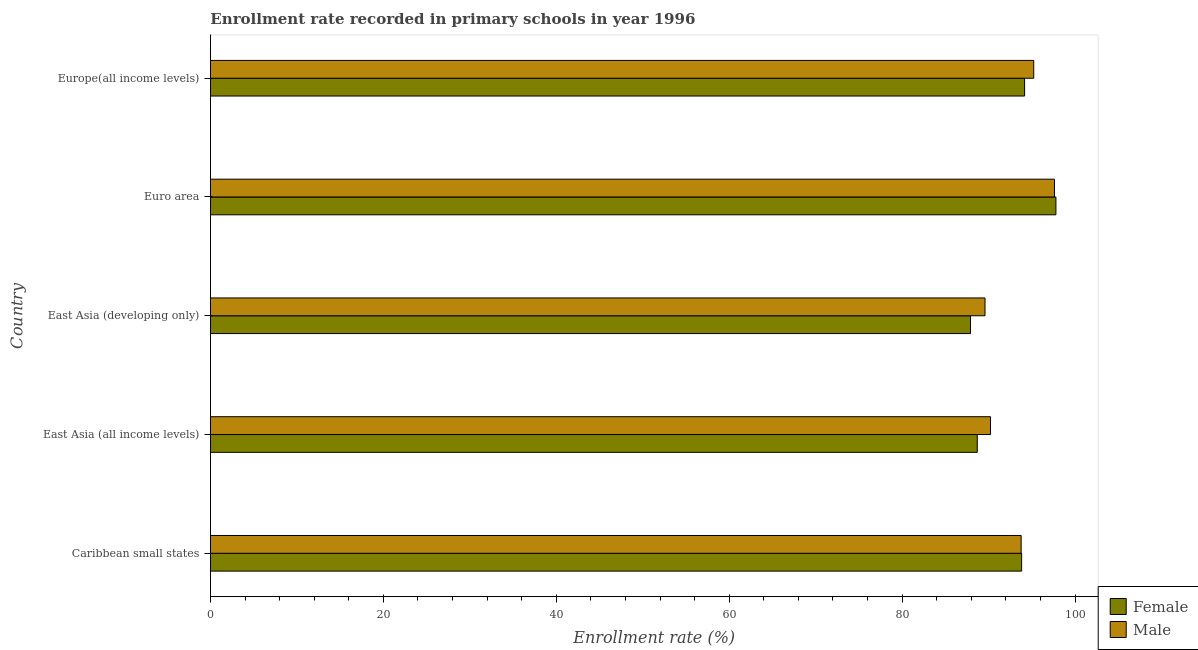How many groups of bars are there?
Ensure brevity in your answer.  5. Are the number of bars per tick equal to the number of legend labels?
Your answer should be compact. Yes. How many bars are there on the 4th tick from the top?
Provide a short and direct response. 2. What is the label of the 4th group of bars from the top?
Your answer should be compact. East Asia (all income levels). In how many cases, is the number of bars for a given country not equal to the number of legend labels?
Provide a short and direct response. 0. What is the enrollment rate of female students in East Asia (all income levels)?
Give a very brief answer. 88.69. Across all countries, what is the maximum enrollment rate of female students?
Ensure brevity in your answer.  97.79. Across all countries, what is the minimum enrollment rate of female students?
Your answer should be compact. 87.91. In which country was the enrollment rate of male students maximum?
Your response must be concise. Euro area. In which country was the enrollment rate of female students minimum?
Offer a very short reply. East Asia (developing only). What is the total enrollment rate of female students in the graph?
Your answer should be very brief. 462.38. What is the difference between the enrollment rate of male students in East Asia (all income levels) and that in Euro area?
Provide a succinct answer. -7.4. What is the difference between the enrollment rate of female students in Europe(all income levels) and the enrollment rate of male students in East Asia (all income levels)?
Offer a very short reply. 3.94. What is the average enrollment rate of female students per country?
Your answer should be very brief. 92.48. What is the difference between the enrollment rate of female students and enrollment rate of male students in Euro area?
Offer a terse response. 0.17. In how many countries, is the enrollment rate of female students greater than 80 %?
Keep it short and to the point. 5. What is the ratio of the enrollment rate of male students in East Asia (developing only) to that in Europe(all income levels)?
Your answer should be compact. 0.94. Is the difference between the enrollment rate of male students in Euro area and Europe(all income levels) greater than the difference between the enrollment rate of female students in Euro area and Europe(all income levels)?
Provide a short and direct response. No. What is the difference between the highest and the second highest enrollment rate of female students?
Offer a very short reply. 3.62. What is the difference between the highest and the lowest enrollment rate of female students?
Your answer should be compact. 9.88. Is the sum of the enrollment rate of male students in Caribbean small states and Europe(all income levels) greater than the maximum enrollment rate of female students across all countries?
Your answer should be very brief. Yes. What does the 1st bar from the top in Europe(all income levels) represents?
Provide a short and direct response. Male. How many bars are there?
Your answer should be very brief. 10. How many legend labels are there?
Make the answer very short. 2. What is the title of the graph?
Your answer should be compact. Enrollment rate recorded in primary schools in year 1996. Does "IMF concessional" appear as one of the legend labels in the graph?
Give a very brief answer. No. What is the label or title of the X-axis?
Your response must be concise. Enrollment rate (%). What is the label or title of the Y-axis?
Your answer should be compact. Country. What is the Enrollment rate (%) in Female in Caribbean small states?
Provide a succinct answer. 93.82. What is the Enrollment rate (%) in Male in Caribbean small states?
Keep it short and to the point. 93.77. What is the Enrollment rate (%) in Female in East Asia (all income levels)?
Provide a short and direct response. 88.69. What is the Enrollment rate (%) of Male in East Asia (all income levels)?
Your response must be concise. 90.22. What is the Enrollment rate (%) in Female in East Asia (developing only)?
Provide a succinct answer. 87.91. What is the Enrollment rate (%) in Male in East Asia (developing only)?
Provide a short and direct response. 89.59. What is the Enrollment rate (%) of Female in Euro area?
Your answer should be very brief. 97.79. What is the Enrollment rate (%) in Male in Euro area?
Give a very brief answer. 97.62. What is the Enrollment rate (%) in Female in Europe(all income levels)?
Your answer should be very brief. 94.16. What is the Enrollment rate (%) of Male in Europe(all income levels)?
Give a very brief answer. 95.22. Across all countries, what is the maximum Enrollment rate (%) of Female?
Provide a succinct answer. 97.79. Across all countries, what is the maximum Enrollment rate (%) of Male?
Offer a very short reply. 97.62. Across all countries, what is the minimum Enrollment rate (%) in Female?
Offer a very short reply. 87.91. Across all countries, what is the minimum Enrollment rate (%) of Male?
Your answer should be compact. 89.59. What is the total Enrollment rate (%) of Female in the graph?
Keep it short and to the point. 462.38. What is the total Enrollment rate (%) of Male in the graph?
Provide a succinct answer. 466.42. What is the difference between the Enrollment rate (%) in Female in Caribbean small states and that in East Asia (all income levels)?
Keep it short and to the point. 5.13. What is the difference between the Enrollment rate (%) of Male in Caribbean small states and that in East Asia (all income levels)?
Offer a very short reply. 3.54. What is the difference between the Enrollment rate (%) in Female in Caribbean small states and that in East Asia (developing only)?
Your answer should be compact. 5.91. What is the difference between the Enrollment rate (%) of Male in Caribbean small states and that in East Asia (developing only)?
Your answer should be very brief. 4.18. What is the difference between the Enrollment rate (%) of Female in Caribbean small states and that in Euro area?
Offer a very short reply. -3.97. What is the difference between the Enrollment rate (%) in Male in Caribbean small states and that in Euro area?
Ensure brevity in your answer.  -3.86. What is the difference between the Enrollment rate (%) of Female in Caribbean small states and that in Europe(all income levels)?
Your response must be concise. -0.34. What is the difference between the Enrollment rate (%) in Male in Caribbean small states and that in Europe(all income levels)?
Offer a terse response. -1.46. What is the difference between the Enrollment rate (%) of Female in East Asia (all income levels) and that in East Asia (developing only)?
Keep it short and to the point. 0.78. What is the difference between the Enrollment rate (%) of Male in East Asia (all income levels) and that in East Asia (developing only)?
Offer a terse response. 0.64. What is the difference between the Enrollment rate (%) of Female in East Asia (all income levels) and that in Euro area?
Your answer should be compact. -9.1. What is the difference between the Enrollment rate (%) in Male in East Asia (all income levels) and that in Euro area?
Provide a short and direct response. -7.4. What is the difference between the Enrollment rate (%) of Female in East Asia (all income levels) and that in Europe(all income levels)?
Ensure brevity in your answer.  -5.47. What is the difference between the Enrollment rate (%) in Male in East Asia (all income levels) and that in Europe(all income levels)?
Your response must be concise. -5. What is the difference between the Enrollment rate (%) of Female in East Asia (developing only) and that in Euro area?
Make the answer very short. -9.88. What is the difference between the Enrollment rate (%) in Male in East Asia (developing only) and that in Euro area?
Provide a succinct answer. -8.04. What is the difference between the Enrollment rate (%) of Female in East Asia (developing only) and that in Europe(all income levels)?
Give a very brief answer. -6.26. What is the difference between the Enrollment rate (%) in Male in East Asia (developing only) and that in Europe(all income levels)?
Make the answer very short. -5.64. What is the difference between the Enrollment rate (%) in Female in Euro area and that in Europe(all income levels)?
Offer a terse response. 3.62. What is the difference between the Enrollment rate (%) in Male in Euro area and that in Europe(all income levels)?
Keep it short and to the point. 2.4. What is the difference between the Enrollment rate (%) of Female in Caribbean small states and the Enrollment rate (%) of Male in East Asia (all income levels)?
Offer a very short reply. 3.6. What is the difference between the Enrollment rate (%) of Female in Caribbean small states and the Enrollment rate (%) of Male in East Asia (developing only)?
Keep it short and to the point. 4.24. What is the difference between the Enrollment rate (%) of Female in Caribbean small states and the Enrollment rate (%) of Male in Euro area?
Your response must be concise. -3.8. What is the difference between the Enrollment rate (%) of Female in Caribbean small states and the Enrollment rate (%) of Male in Europe(all income levels)?
Offer a terse response. -1.4. What is the difference between the Enrollment rate (%) of Female in East Asia (all income levels) and the Enrollment rate (%) of Male in East Asia (developing only)?
Your answer should be very brief. -0.9. What is the difference between the Enrollment rate (%) of Female in East Asia (all income levels) and the Enrollment rate (%) of Male in Euro area?
Your response must be concise. -8.93. What is the difference between the Enrollment rate (%) of Female in East Asia (all income levels) and the Enrollment rate (%) of Male in Europe(all income levels)?
Provide a short and direct response. -6.53. What is the difference between the Enrollment rate (%) of Female in East Asia (developing only) and the Enrollment rate (%) of Male in Euro area?
Your answer should be very brief. -9.71. What is the difference between the Enrollment rate (%) in Female in East Asia (developing only) and the Enrollment rate (%) in Male in Europe(all income levels)?
Your answer should be very brief. -7.31. What is the difference between the Enrollment rate (%) of Female in Euro area and the Enrollment rate (%) of Male in Europe(all income levels)?
Provide a short and direct response. 2.57. What is the average Enrollment rate (%) in Female per country?
Make the answer very short. 92.48. What is the average Enrollment rate (%) of Male per country?
Provide a succinct answer. 93.28. What is the difference between the Enrollment rate (%) of Female and Enrollment rate (%) of Male in Caribbean small states?
Provide a short and direct response. 0.06. What is the difference between the Enrollment rate (%) in Female and Enrollment rate (%) in Male in East Asia (all income levels)?
Your answer should be very brief. -1.53. What is the difference between the Enrollment rate (%) in Female and Enrollment rate (%) in Male in East Asia (developing only)?
Offer a terse response. -1.68. What is the difference between the Enrollment rate (%) in Female and Enrollment rate (%) in Male in Euro area?
Provide a succinct answer. 0.17. What is the difference between the Enrollment rate (%) of Female and Enrollment rate (%) of Male in Europe(all income levels)?
Provide a succinct answer. -1.06. What is the ratio of the Enrollment rate (%) of Female in Caribbean small states to that in East Asia (all income levels)?
Keep it short and to the point. 1.06. What is the ratio of the Enrollment rate (%) of Male in Caribbean small states to that in East Asia (all income levels)?
Your response must be concise. 1.04. What is the ratio of the Enrollment rate (%) in Female in Caribbean small states to that in East Asia (developing only)?
Give a very brief answer. 1.07. What is the ratio of the Enrollment rate (%) in Male in Caribbean small states to that in East Asia (developing only)?
Your answer should be very brief. 1.05. What is the ratio of the Enrollment rate (%) of Female in Caribbean small states to that in Euro area?
Give a very brief answer. 0.96. What is the ratio of the Enrollment rate (%) in Male in Caribbean small states to that in Euro area?
Your answer should be very brief. 0.96. What is the ratio of the Enrollment rate (%) of Female in Caribbean small states to that in Europe(all income levels)?
Your answer should be compact. 1. What is the ratio of the Enrollment rate (%) of Male in Caribbean small states to that in Europe(all income levels)?
Offer a very short reply. 0.98. What is the ratio of the Enrollment rate (%) in Female in East Asia (all income levels) to that in East Asia (developing only)?
Ensure brevity in your answer.  1.01. What is the ratio of the Enrollment rate (%) of Male in East Asia (all income levels) to that in East Asia (developing only)?
Provide a short and direct response. 1.01. What is the ratio of the Enrollment rate (%) in Female in East Asia (all income levels) to that in Euro area?
Provide a succinct answer. 0.91. What is the ratio of the Enrollment rate (%) in Male in East Asia (all income levels) to that in Euro area?
Your answer should be compact. 0.92. What is the ratio of the Enrollment rate (%) in Female in East Asia (all income levels) to that in Europe(all income levels)?
Your answer should be compact. 0.94. What is the ratio of the Enrollment rate (%) of Male in East Asia (all income levels) to that in Europe(all income levels)?
Keep it short and to the point. 0.95. What is the ratio of the Enrollment rate (%) of Female in East Asia (developing only) to that in Euro area?
Provide a short and direct response. 0.9. What is the ratio of the Enrollment rate (%) of Male in East Asia (developing only) to that in Euro area?
Offer a terse response. 0.92. What is the ratio of the Enrollment rate (%) in Female in East Asia (developing only) to that in Europe(all income levels)?
Make the answer very short. 0.93. What is the ratio of the Enrollment rate (%) of Male in East Asia (developing only) to that in Europe(all income levels)?
Offer a very short reply. 0.94. What is the ratio of the Enrollment rate (%) of Male in Euro area to that in Europe(all income levels)?
Offer a terse response. 1.03. What is the difference between the highest and the second highest Enrollment rate (%) in Female?
Your answer should be compact. 3.62. What is the difference between the highest and the second highest Enrollment rate (%) of Male?
Give a very brief answer. 2.4. What is the difference between the highest and the lowest Enrollment rate (%) of Female?
Make the answer very short. 9.88. What is the difference between the highest and the lowest Enrollment rate (%) in Male?
Your response must be concise. 8.04. 